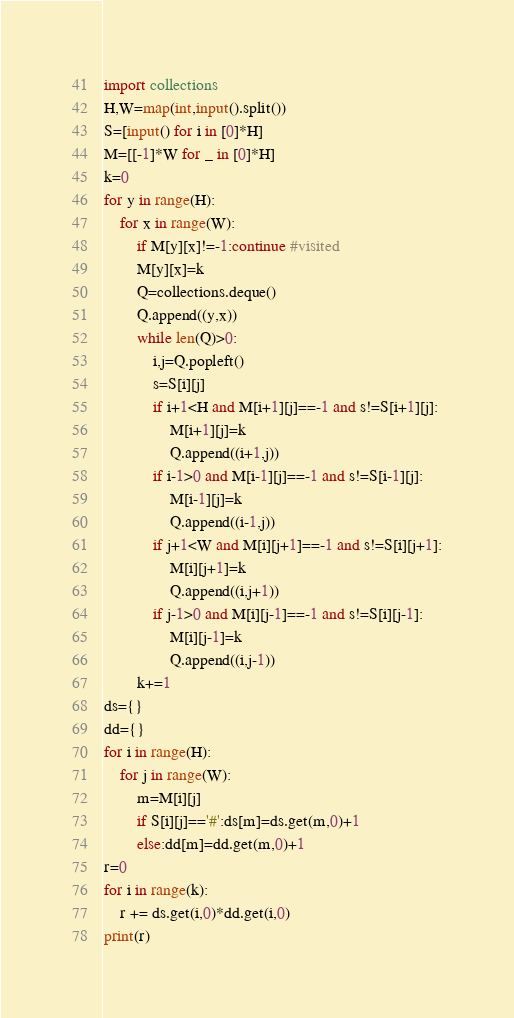Convert code to text. <code><loc_0><loc_0><loc_500><loc_500><_Python_>import collections
H,W=map(int,input().split())
S=[input() for i in [0]*H]
M=[[-1]*W for _ in [0]*H]
k=0
for y in range(H):
    for x in range(W):
        if M[y][x]!=-1:continue #visited
        M[y][x]=k
        Q=collections.deque()
        Q.append((y,x))
        while len(Q)>0:
            i,j=Q.popleft()
            s=S[i][j]
            if i+1<H and M[i+1][j]==-1 and s!=S[i+1][j]:
                M[i+1][j]=k
                Q.append((i+1,j))
            if i-1>0 and M[i-1][j]==-1 and s!=S[i-1][j]:
                M[i-1][j]=k
                Q.append((i-1,j))
            if j+1<W and M[i][j+1]==-1 and s!=S[i][j+1]:
                M[i][j+1]=k
                Q.append((i,j+1))
            if j-1>0 and M[i][j-1]==-1 and s!=S[i][j-1]:
                M[i][j-1]=k
                Q.append((i,j-1))
        k+=1
ds={}
dd={}
for i in range(H):
    for j in range(W):
        m=M[i][j]
        if S[i][j]=='#':ds[m]=ds.get(m,0)+1
        else:dd[m]=dd.get(m,0)+1
r=0
for i in range(k):
    r += ds.get(i,0)*dd.get(i,0)
print(r)</code> 